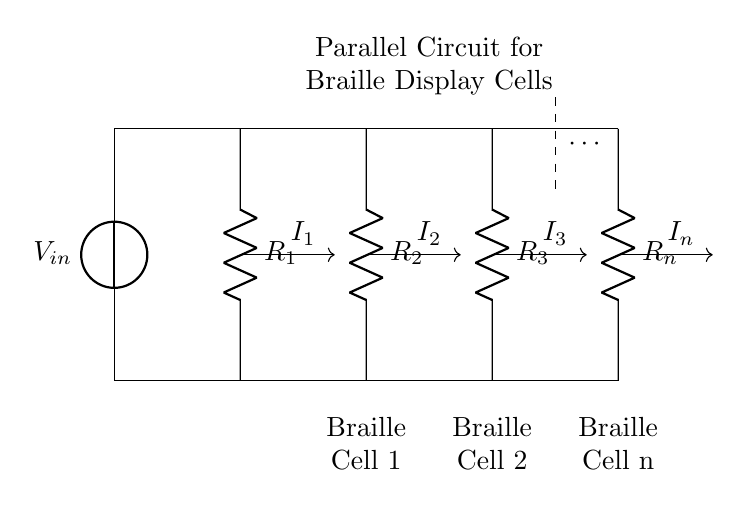What is the input voltage of the circuit? The input voltage, labeled as V_in, is the voltage supplied to the circuit from the voltage source.
Answer: V_in How many resistors are present in the circuit? The circuit contains four resistors, each labeled from R_1 to R_n.
Answer: 4 What type of circuit is shown in the diagram? The circuit is a parallel circuit, as indicated by the connections where multiple branches are connected to the same voltage source and share the same potential.
Answer: Parallel What does I_1 represent in the circuit? I_1 represents the current flowing through the first branch that includes resistor R_1, and is depicted with an arrow indicating direction.
Answer: Current through R_1 If the resistors are equal, what can be said about the current through each resistor? If the resistors are equal, the current divides equally among them due to the current divider rule, meaning that each resistor receives the same amount of current.
Answer: Equal currents What is the purpose of connecting the Braille cells in parallel? The purpose of connecting the Braille cells in parallel is to ensure that each cell receives the same voltage, which allows for simultaneous operation while maintaining individual current control.
Answer: Simultaneous operation How do you calculate the total current entering the circuit? The total current entering the circuit can be calculated by adding the individual currents through each branch (I_1, I_2, I_3, I_n) according to the current divider formula or simply summing them if resistances are equal.
Answer: Sum of currents 